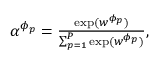<formula> <loc_0><loc_0><loc_500><loc_500>\begin{array} { r } { \begin{array} { r } { \alpha ^ { \phi _ { p } } = \frac { \exp ( w ^ { \phi _ { p } } ) } { \sum _ { p = 1 } ^ { P } \exp ( w ^ { \phi _ { p } } ) } , } \end{array} } \end{array}</formula> 